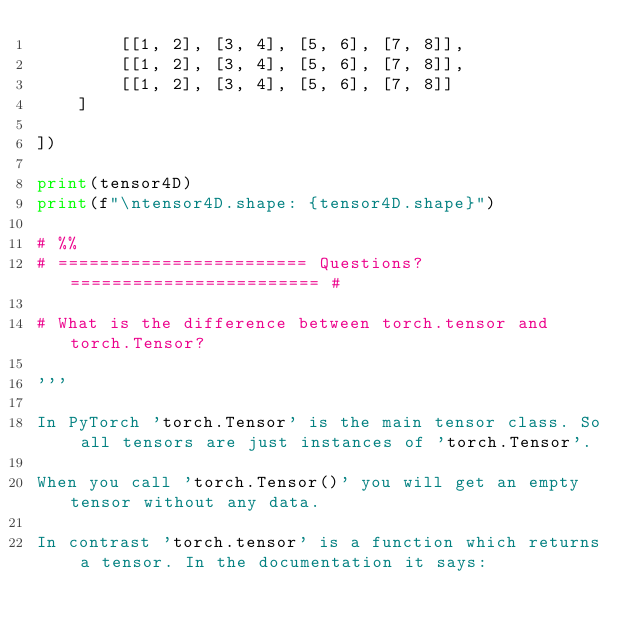Convert code to text. <code><loc_0><loc_0><loc_500><loc_500><_Python_>        [[1, 2], [3, 4], [5, 6], [7, 8]],
        [[1, 2], [3, 4], [5, 6], [7, 8]],
        [[1, 2], [3, 4], [5, 6], [7, 8]]
    ]

])

print(tensor4D)
print(f"\ntensor4D.shape: {tensor4D.shape}")

# %%
# ======================== Questions? ======================== #

# What is the difference between torch.tensor and torch.Tensor?

'''

In PyTorch 'torch.Tensor' is the main tensor class. So all tensors are just instances of 'torch.Tensor'.

When you call 'torch.Tensor()' you will get an empty tensor without any data.

In contrast 'torch.tensor' is a function which returns a tensor. In the documentation it says:
</code> 